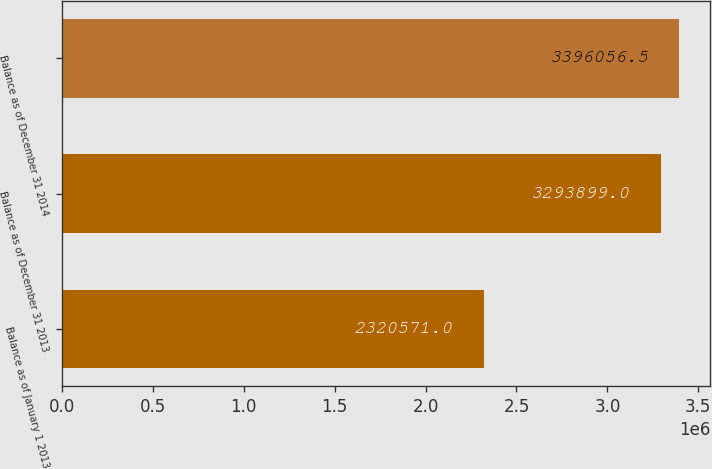<chart> <loc_0><loc_0><loc_500><loc_500><bar_chart><fcel>Balance as of January 1 2013<fcel>Balance as of December 31 2013<fcel>Balance as of December 31 2014<nl><fcel>2.32057e+06<fcel>3.2939e+06<fcel>3.39606e+06<nl></chart> 